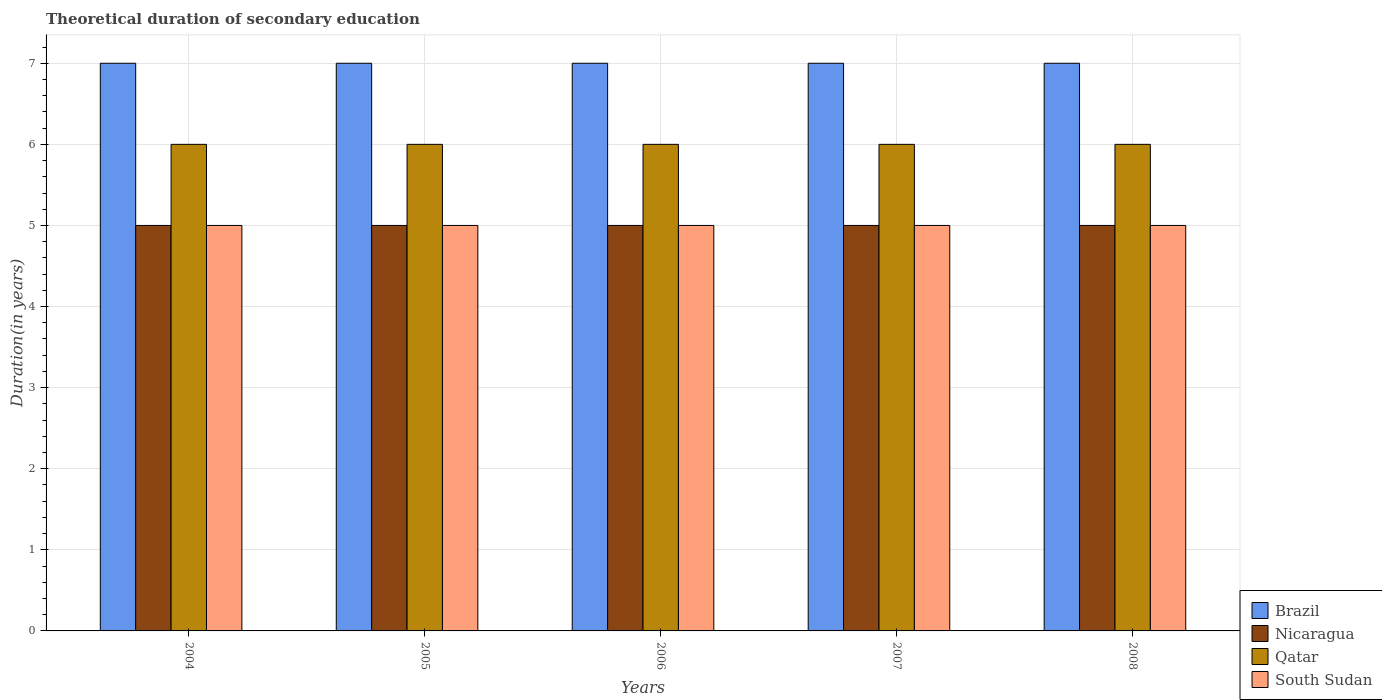Are the number of bars per tick equal to the number of legend labels?
Give a very brief answer. Yes. How many bars are there on the 5th tick from the right?
Your response must be concise. 4. In how many cases, is the number of bars for a given year not equal to the number of legend labels?
Provide a short and direct response. 0. In which year was the total theoretical duration of secondary education in South Sudan maximum?
Offer a very short reply. 2004. In which year was the total theoretical duration of secondary education in South Sudan minimum?
Your answer should be compact. 2004. What is the total total theoretical duration of secondary education in South Sudan in the graph?
Keep it short and to the point. 25. What is the difference between the total theoretical duration of secondary education in South Sudan in 2005 and that in 2007?
Ensure brevity in your answer.  0. What is the difference between the total theoretical duration of secondary education in Qatar in 2007 and the total theoretical duration of secondary education in Nicaragua in 2005?
Your response must be concise. 1. What is the average total theoretical duration of secondary education in Qatar per year?
Your response must be concise. 6. In how many years, is the total theoretical duration of secondary education in Nicaragua greater than 6.8 years?
Your answer should be compact. 0. Is the difference between the total theoretical duration of secondary education in South Sudan in 2006 and 2008 greater than the difference between the total theoretical duration of secondary education in Nicaragua in 2006 and 2008?
Ensure brevity in your answer.  No. In how many years, is the total theoretical duration of secondary education in Brazil greater than the average total theoretical duration of secondary education in Brazil taken over all years?
Offer a terse response. 0. What does the 2nd bar from the left in 2006 represents?
Your response must be concise. Nicaragua. What does the 2nd bar from the right in 2008 represents?
Make the answer very short. Qatar. Does the graph contain any zero values?
Your answer should be very brief. No. Does the graph contain grids?
Offer a terse response. Yes. How are the legend labels stacked?
Provide a succinct answer. Vertical. What is the title of the graph?
Ensure brevity in your answer.  Theoretical duration of secondary education. What is the label or title of the Y-axis?
Provide a succinct answer. Duration(in years). What is the Duration(in years) in Brazil in 2004?
Keep it short and to the point. 7. What is the Duration(in years) in Qatar in 2004?
Ensure brevity in your answer.  6. What is the Duration(in years) in South Sudan in 2004?
Provide a short and direct response. 5. What is the Duration(in years) of Brazil in 2005?
Offer a very short reply. 7. What is the Duration(in years) of Qatar in 2005?
Provide a short and direct response. 6. What is the Duration(in years) of Qatar in 2006?
Provide a short and direct response. 6. What is the Duration(in years) in South Sudan in 2006?
Provide a succinct answer. 5. What is the Duration(in years) in Nicaragua in 2007?
Ensure brevity in your answer.  5. What is the Duration(in years) in Nicaragua in 2008?
Keep it short and to the point. 5. What is the Duration(in years) in South Sudan in 2008?
Make the answer very short. 5. Across all years, what is the maximum Duration(in years) in Brazil?
Offer a terse response. 7. Across all years, what is the maximum Duration(in years) in Qatar?
Keep it short and to the point. 6. Across all years, what is the maximum Duration(in years) in South Sudan?
Offer a terse response. 5. Across all years, what is the minimum Duration(in years) of Nicaragua?
Give a very brief answer. 5. What is the total Duration(in years) of Nicaragua in the graph?
Your answer should be very brief. 25. What is the difference between the Duration(in years) in Brazil in 2004 and that in 2005?
Your answer should be compact. 0. What is the difference between the Duration(in years) of Nicaragua in 2004 and that in 2005?
Your answer should be very brief. 0. What is the difference between the Duration(in years) in South Sudan in 2004 and that in 2005?
Ensure brevity in your answer.  0. What is the difference between the Duration(in years) in Brazil in 2004 and that in 2006?
Ensure brevity in your answer.  0. What is the difference between the Duration(in years) of Nicaragua in 2004 and that in 2006?
Your response must be concise. 0. What is the difference between the Duration(in years) of Brazil in 2004 and that in 2007?
Ensure brevity in your answer.  0. What is the difference between the Duration(in years) in Qatar in 2004 and that in 2007?
Give a very brief answer. 0. What is the difference between the Duration(in years) of South Sudan in 2004 and that in 2007?
Offer a terse response. 0. What is the difference between the Duration(in years) in Brazil in 2004 and that in 2008?
Offer a very short reply. 0. What is the difference between the Duration(in years) of Nicaragua in 2004 and that in 2008?
Your response must be concise. 0. What is the difference between the Duration(in years) in Qatar in 2004 and that in 2008?
Give a very brief answer. 0. What is the difference between the Duration(in years) of Brazil in 2005 and that in 2007?
Your answer should be very brief. 0. What is the difference between the Duration(in years) in Nicaragua in 2005 and that in 2007?
Provide a short and direct response. 0. What is the difference between the Duration(in years) of Qatar in 2005 and that in 2007?
Ensure brevity in your answer.  0. What is the difference between the Duration(in years) of Brazil in 2005 and that in 2008?
Your answer should be compact. 0. What is the difference between the Duration(in years) in Brazil in 2006 and that in 2007?
Keep it short and to the point. 0. What is the difference between the Duration(in years) of Nicaragua in 2006 and that in 2007?
Ensure brevity in your answer.  0. What is the difference between the Duration(in years) of Qatar in 2006 and that in 2007?
Provide a succinct answer. 0. What is the difference between the Duration(in years) in Brazil in 2006 and that in 2008?
Offer a terse response. 0. What is the difference between the Duration(in years) of Brazil in 2007 and that in 2008?
Your answer should be compact. 0. What is the difference between the Duration(in years) of Nicaragua in 2007 and that in 2008?
Your response must be concise. 0. What is the difference between the Duration(in years) in Brazil in 2004 and the Duration(in years) in Nicaragua in 2005?
Give a very brief answer. 2. What is the difference between the Duration(in years) in Brazil in 2004 and the Duration(in years) in Qatar in 2005?
Your response must be concise. 1. What is the difference between the Duration(in years) in Nicaragua in 2004 and the Duration(in years) in Qatar in 2005?
Your answer should be very brief. -1. What is the difference between the Duration(in years) in Brazil in 2004 and the Duration(in years) in Nicaragua in 2006?
Keep it short and to the point. 2. What is the difference between the Duration(in years) of Nicaragua in 2004 and the Duration(in years) of South Sudan in 2006?
Your response must be concise. 0. What is the difference between the Duration(in years) in Qatar in 2004 and the Duration(in years) in South Sudan in 2006?
Keep it short and to the point. 1. What is the difference between the Duration(in years) in Brazil in 2004 and the Duration(in years) in Nicaragua in 2007?
Your answer should be very brief. 2. What is the difference between the Duration(in years) of Brazil in 2004 and the Duration(in years) of Qatar in 2007?
Offer a very short reply. 1. What is the difference between the Duration(in years) of Qatar in 2004 and the Duration(in years) of South Sudan in 2007?
Ensure brevity in your answer.  1. What is the difference between the Duration(in years) in Brazil in 2004 and the Duration(in years) in Nicaragua in 2008?
Provide a succinct answer. 2. What is the difference between the Duration(in years) in Nicaragua in 2004 and the Duration(in years) in South Sudan in 2008?
Ensure brevity in your answer.  0. What is the difference between the Duration(in years) in Brazil in 2005 and the Duration(in years) in Nicaragua in 2006?
Ensure brevity in your answer.  2. What is the difference between the Duration(in years) of Nicaragua in 2005 and the Duration(in years) of Qatar in 2006?
Provide a succinct answer. -1. What is the difference between the Duration(in years) of Nicaragua in 2005 and the Duration(in years) of South Sudan in 2006?
Make the answer very short. 0. What is the difference between the Duration(in years) in Qatar in 2005 and the Duration(in years) in South Sudan in 2006?
Provide a succinct answer. 1. What is the difference between the Duration(in years) in Brazil in 2005 and the Duration(in years) in Qatar in 2007?
Provide a short and direct response. 1. What is the difference between the Duration(in years) of Qatar in 2005 and the Duration(in years) of South Sudan in 2007?
Give a very brief answer. 1. What is the difference between the Duration(in years) in Brazil in 2005 and the Duration(in years) in South Sudan in 2008?
Offer a terse response. 2. What is the difference between the Duration(in years) in Qatar in 2005 and the Duration(in years) in South Sudan in 2008?
Ensure brevity in your answer.  1. What is the difference between the Duration(in years) in Brazil in 2006 and the Duration(in years) in Nicaragua in 2007?
Keep it short and to the point. 2. What is the difference between the Duration(in years) in Nicaragua in 2006 and the Duration(in years) in Qatar in 2007?
Offer a very short reply. -1. What is the difference between the Duration(in years) in Nicaragua in 2006 and the Duration(in years) in South Sudan in 2007?
Provide a succinct answer. 0. What is the difference between the Duration(in years) in Brazil in 2006 and the Duration(in years) in Nicaragua in 2008?
Provide a succinct answer. 2. What is the difference between the Duration(in years) in Brazil in 2006 and the Duration(in years) in South Sudan in 2008?
Ensure brevity in your answer.  2. What is the difference between the Duration(in years) of Nicaragua in 2006 and the Duration(in years) of Qatar in 2008?
Ensure brevity in your answer.  -1. What is the difference between the Duration(in years) of Nicaragua in 2006 and the Duration(in years) of South Sudan in 2008?
Keep it short and to the point. 0. What is the difference between the Duration(in years) in Qatar in 2006 and the Duration(in years) in South Sudan in 2008?
Provide a short and direct response. 1. What is the difference between the Duration(in years) of Brazil in 2007 and the Duration(in years) of Nicaragua in 2008?
Provide a short and direct response. 2. What is the difference between the Duration(in years) in Brazil in 2007 and the Duration(in years) in South Sudan in 2008?
Make the answer very short. 2. What is the average Duration(in years) in Brazil per year?
Provide a succinct answer. 7. What is the average Duration(in years) of Nicaragua per year?
Keep it short and to the point. 5. What is the average Duration(in years) in Qatar per year?
Your answer should be compact. 6. In the year 2004, what is the difference between the Duration(in years) in Brazil and Duration(in years) in Nicaragua?
Offer a terse response. 2. In the year 2004, what is the difference between the Duration(in years) in Brazil and Duration(in years) in Qatar?
Ensure brevity in your answer.  1. In the year 2004, what is the difference between the Duration(in years) of Brazil and Duration(in years) of South Sudan?
Make the answer very short. 2. In the year 2004, what is the difference between the Duration(in years) in Nicaragua and Duration(in years) in South Sudan?
Provide a succinct answer. 0. In the year 2005, what is the difference between the Duration(in years) of Brazil and Duration(in years) of Nicaragua?
Your response must be concise. 2. In the year 2005, what is the difference between the Duration(in years) in Brazil and Duration(in years) in Qatar?
Provide a short and direct response. 1. In the year 2005, what is the difference between the Duration(in years) of Nicaragua and Duration(in years) of Qatar?
Offer a very short reply. -1. In the year 2005, what is the difference between the Duration(in years) of Nicaragua and Duration(in years) of South Sudan?
Provide a short and direct response. 0. In the year 2005, what is the difference between the Duration(in years) of Qatar and Duration(in years) of South Sudan?
Give a very brief answer. 1. In the year 2006, what is the difference between the Duration(in years) of Brazil and Duration(in years) of Nicaragua?
Ensure brevity in your answer.  2. In the year 2006, what is the difference between the Duration(in years) in Brazil and Duration(in years) in Qatar?
Offer a terse response. 1. In the year 2006, what is the difference between the Duration(in years) of Brazil and Duration(in years) of South Sudan?
Offer a very short reply. 2. In the year 2006, what is the difference between the Duration(in years) in Qatar and Duration(in years) in South Sudan?
Give a very brief answer. 1. In the year 2007, what is the difference between the Duration(in years) of Brazil and Duration(in years) of Qatar?
Give a very brief answer. 1. In the year 2007, what is the difference between the Duration(in years) of Brazil and Duration(in years) of South Sudan?
Provide a succinct answer. 2. In the year 2007, what is the difference between the Duration(in years) of Nicaragua and Duration(in years) of Qatar?
Provide a succinct answer. -1. In the year 2008, what is the difference between the Duration(in years) in Brazil and Duration(in years) in Nicaragua?
Your response must be concise. 2. In the year 2008, what is the difference between the Duration(in years) in Brazil and Duration(in years) in Qatar?
Offer a terse response. 1. In the year 2008, what is the difference between the Duration(in years) of Brazil and Duration(in years) of South Sudan?
Provide a succinct answer. 2. In the year 2008, what is the difference between the Duration(in years) of Qatar and Duration(in years) of South Sudan?
Offer a terse response. 1. What is the ratio of the Duration(in years) of Brazil in 2004 to that in 2006?
Give a very brief answer. 1. What is the ratio of the Duration(in years) in Nicaragua in 2004 to that in 2006?
Ensure brevity in your answer.  1. What is the ratio of the Duration(in years) of Qatar in 2004 to that in 2006?
Offer a very short reply. 1. What is the ratio of the Duration(in years) in South Sudan in 2004 to that in 2006?
Offer a very short reply. 1. What is the ratio of the Duration(in years) of Qatar in 2004 to that in 2007?
Offer a very short reply. 1. What is the ratio of the Duration(in years) of South Sudan in 2004 to that in 2007?
Your answer should be very brief. 1. What is the ratio of the Duration(in years) in Brazil in 2004 to that in 2008?
Give a very brief answer. 1. What is the ratio of the Duration(in years) of South Sudan in 2004 to that in 2008?
Give a very brief answer. 1. What is the ratio of the Duration(in years) in Nicaragua in 2005 to that in 2006?
Make the answer very short. 1. What is the ratio of the Duration(in years) in South Sudan in 2005 to that in 2006?
Offer a terse response. 1. What is the ratio of the Duration(in years) in Brazil in 2005 to that in 2007?
Your answer should be compact. 1. What is the ratio of the Duration(in years) in Qatar in 2005 to that in 2007?
Make the answer very short. 1. What is the ratio of the Duration(in years) in South Sudan in 2005 to that in 2007?
Offer a terse response. 1. What is the ratio of the Duration(in years) in Brazil in 2005 to that in 2008?
Your answer should be very brief. 1. What is the ratio of the Duration(in years) in Qatar in 2005 to that in 2008?
Ensure brevity in your answer.  1. What is the ratio of the Duration(in years) of South Sudan in 2005 to that in 2008?
Your answer should be compact. 1. What is the ratio of the Duration(in years) in Brazil in 2006 to that in 2007?
Offer a very short reply. 1. What is the ratio of the Duration(in years) of Qatar in 2006 to that in 2007?
Keep it short and to the point. 1. What is the ratio of the Duration(in years) in South Sudan in 2006 to that in 2007?
Your answer should be very brief. 1. What is the ratio of the Duration(in years) in Brazil in 2007 to that in 2008?
Your answer should be very brief. 1. What is the ratio of the Duration(in years) in Nicaragua in 2007 to that in 2008?
Your answer should be very brief. 1. What is the ratio of the Duration(in years) of South Sudan in 2007 to that in 2008?
Your answer should be very brief. 1. What is the difference between the highest and the second highest Duration(in years) in Nicaragua?
Provide a short and direct response. 0. What is the difference between the highest and the second highest Duration(in years) in South Sudan?
Offer a terse response. 0. 